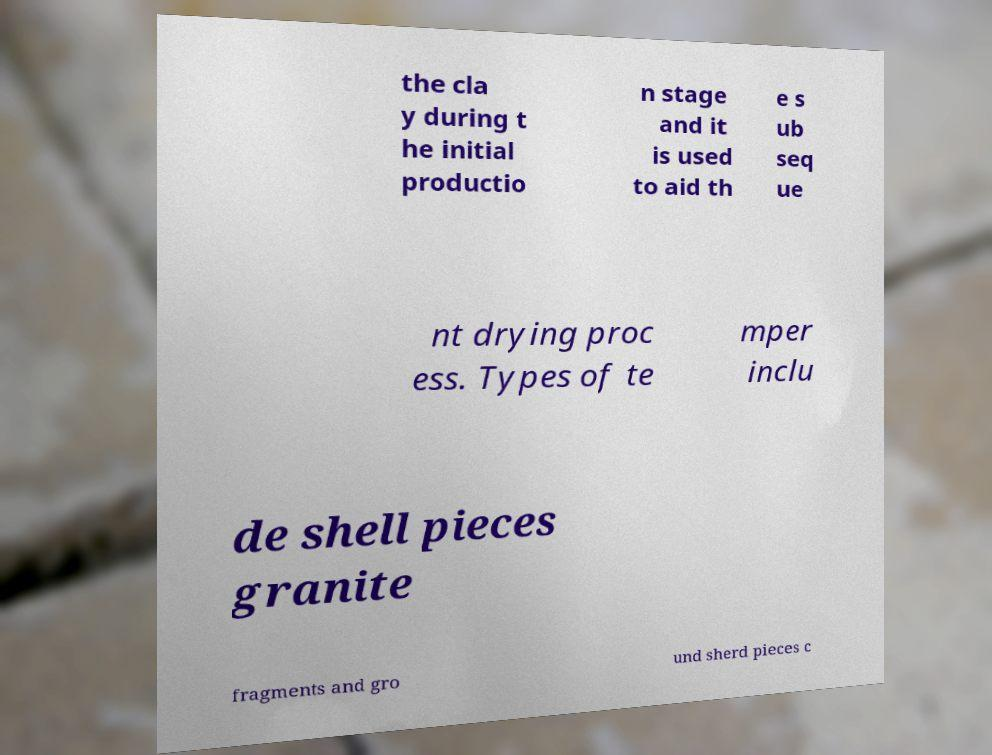Can you read and provide the text displayed in the image?This photo seems to have some interesting text. Can you extract and type it out for me? the cla y during t he initial productio n stage and it is used to aid th e s ub seq ue nt drying proc ess. Types of te mper inclu de shell pieces granite fragments and gro und sherd pieces c 